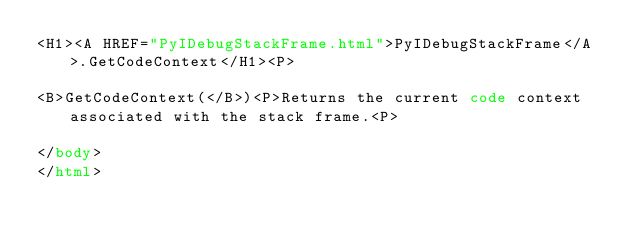<code> <loc_0><loc_0><loc_500><loc_500><_HTML_><H1><A HREF="PyIDebugStackFrame.html">PyIDebugStackFrame</A>.GetCodeContext</H1><P>

<B>GetCodeContext(</B>)<P>Returns the current code context associated with the stack frame.<P>

</body>
</html></code> 